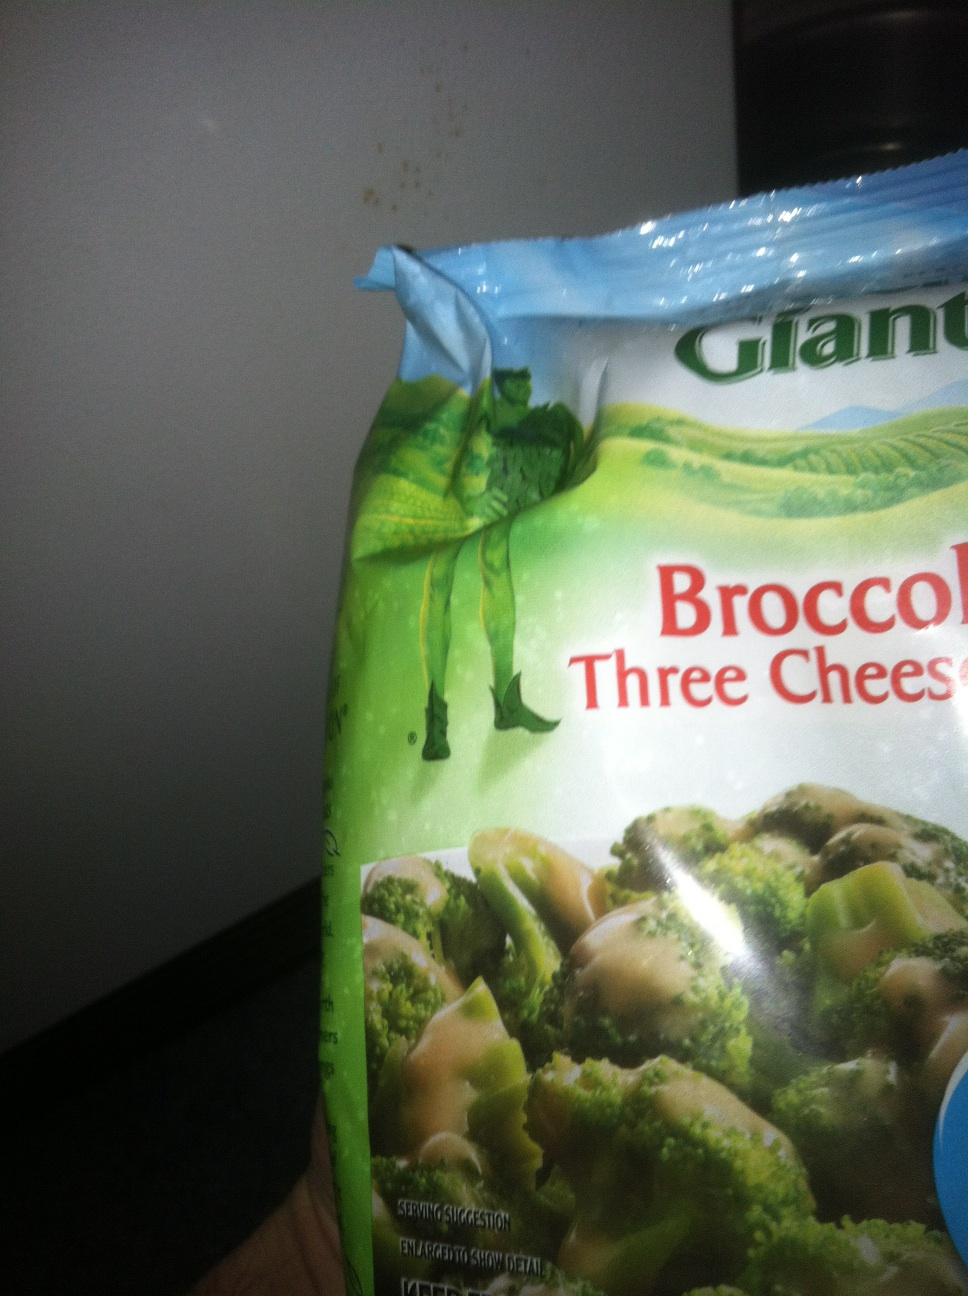Can you describe what you see in detail? This is an image of a package of frozen vegetables. The package is labeled 'Green Giant Broccoli Three Cheese Sauce.' The packaging features a picture of broccoli florets topped with a creamy cheese sauce. The bag is designed with a green color theme, and prominently features the Green Giant logo and an image of a green giant character. What could you do with this product in a meal? You could use this broccoli three cheese sauce in various ways to make delicious meals. It could be served as a side dish accompanying a main course such as grilled chicken, steak, or fish. You could also mix it into a pasta for a quick and easy broccoli and cheese pasta dish. Alternatively, you could use it as a topping on baked potatoes or as a filling in a vegetable quesadilla for a cheesy twist. The possibilities are endless! Imagine a creative way to use this product. You could create a broccoli cheese soup by blending the broccoli and cheese sauce with some chicken or vegetable broth, adding in some additional spices and seasonings for flavor. For a bit more creativity, you could even make a cheesy broccoli pizza crust! Just blend the broccoli and cheese sauce with some eggs and almond flour, shape into a crust, bake it, and then add your favorite pizza toppings. 